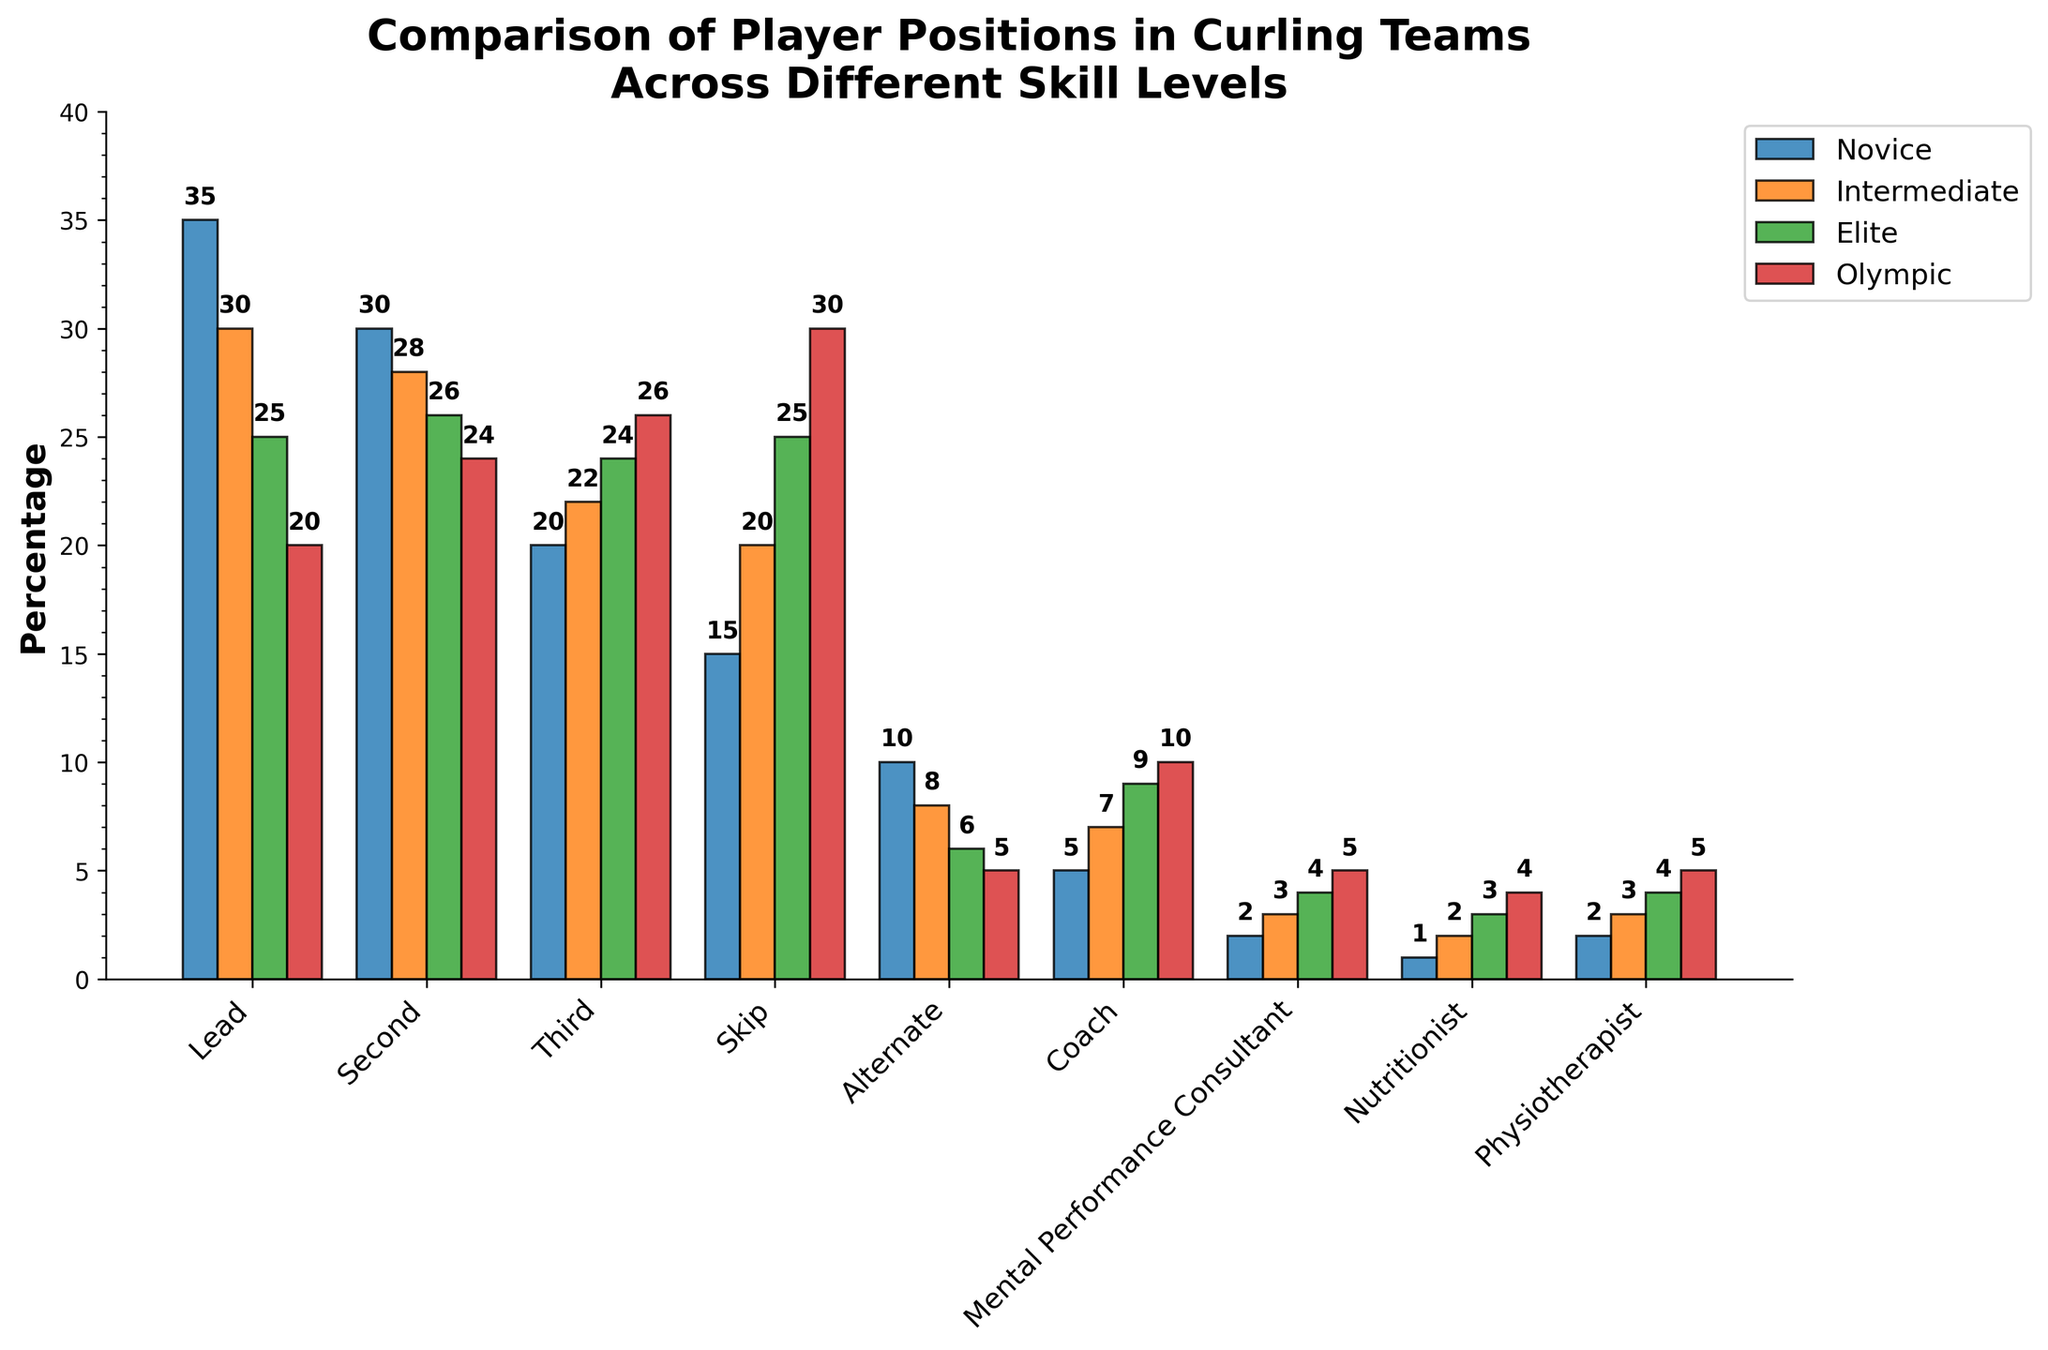What player position has the highest percentage in Olympic-level curling teams? The highest percentage can be identified by looking at the tallest bar in the Olympic category. The Skip position has the tallest bar at 30%.
Answer: Skip How does the percentage of Lead players change from novice to Olympic skill levels? Observe the bars representing Lead players across different skill levels. For Novice, the percentage is 35%, decreasing to 30% for Intermediate, 25% for Elite, and 20% for Olympic. This shows a decreasing trend.
Answer: Decreases What is the combined percentage of Alternates and Coaches at the Elite skill level? Add the percentages of Alternates and Coaches at the Elite level: 6% (Alternate) + 9% (Coach) = 15%.
Answer: 15% Which two positions have the same percentage in the Olympic-level teams, and what is that percentage? Identify the bars with equal heights in the Olympic category. Both the Mental Performance Consultant and Physiotherapist have bars at 5%.
Answer: Mental Performance Consultant and Physiotherapist, 5% Compare the percentage of Skips and Leads at the Intermediate skill level. Which one is higher? Evaluate the bar heights for Skip and Lead at the Intermediate level. Skip has 20%, while Lead has 30%. Lead is higher.
Answer: Lead What is the difference in percentage between the highest and lowest positions in Novice teams? For Novice, the highest percentage is Lead at 35%, and the lowest is Nutritionist at 1%. The difference is 35% - 1% = 34%.
Answer: 34% What is the trend in the percentage of Second players from Novice to Olympic levels? Analyze the bars for Second players across skill levels. It goes from 30% (Novice) to 28% (Intermediate), 26% (Elite), and 24% (Olympic). This indicates a decreasing trend.
Answer: Decreases What is the average percentage of Skips across all skill levels? Sum the percentages of Skips across all levels (15% + 20% + 25% + 30%) and divide by 4: (15 + 20 + 25 + 30) / 4 = 22.5%.
Answer: 22.5% If you combine the percentage of Third and Coach positions at the Intermediate level, is it more or less than the percentage of Lead players at the same level? The Third position is 22%, and the Coach is 7%. Combined, they are 22% + 7% = 29%, which is less than the Lead at 30%.
Answer: Less For which skill level is the difference in percentage between Third and Skip players the smallest? Calculate the difference for each level: Novice (5%), Intermediate (2%), Elite (1%), Olympic (4%). The smallest difference is at the Elite level (1%).
Answer: Elite 